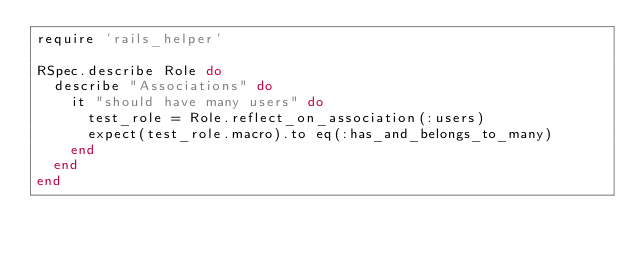<code> <loc_0><loc_0><loc_500><loc_500><_Ruby_>require 'rails_helper'

RSpec.describe Role do
  describe "Associations" do
    it "should have many users" do
      test_role = Role.reflect_on_association(:users)
      expect(test_role.macro).to eq(:has_and_belongs_to_many)
    end
  end
end</code> 